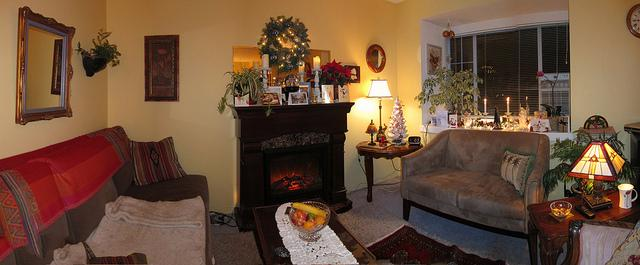What is the white object on the coffee table called?

Choices:
A) doily
B) towel
C) cover
D) tablecloth doily 